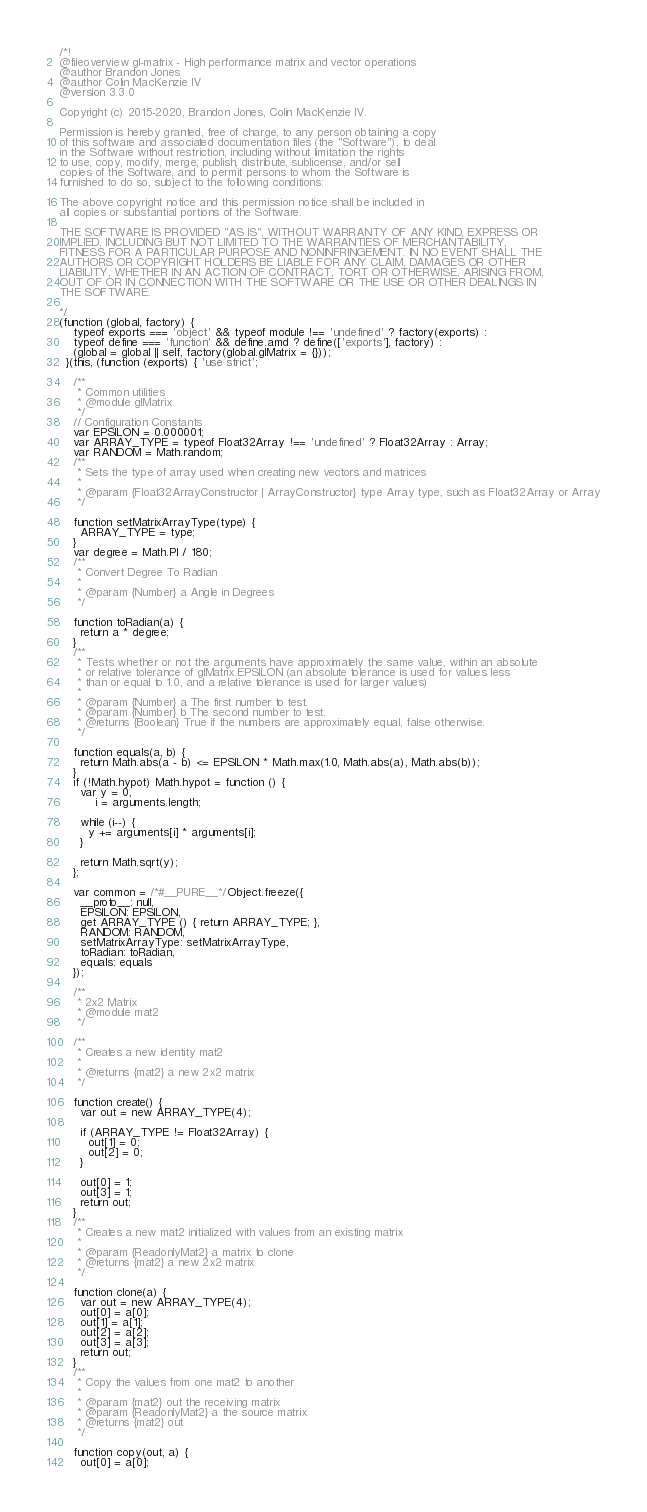<code> <loc_0><loc_0><loc_500><loc_500><_JavaScript_>
/*!
@fileoverview gl-matrix - High performance matrix and vector operations
@author Brandon Jones
@author Colin MacKenzie IV
@version 3.3.0

Copyright (c) 2015-2020, Brandon Jones, Colin MacKenzie IV.

Permission is hereby granted, free of charge, to any person obtaining a copy
of this software and associated documentation files (the "Software"), to deal
in the Software without restriction, including without limitation the rights
to use, copy, modify, merge, publish, distribute, sublicense, and/or sell
copies of the Software, and to permit persons to whom the Software is
furnished to do so, subject to the following conditions:

The above copyright notice and this permission notice shall be included in
all copies or substantial portions of the Software.

THE SOFTWARE IS PROVIDED "AS IS", WITHOUT WARRANTY OF ANY KIND, EXPRESS OR
IMPLIED, INCLUDING BUT NOT LIMITED TO THE WARRANTIES OF MERCHANTABILITY,
FITNESS FOR A PARTICULAR PURPOSE AND NONINFRINGEMENT. IN NO EVENT SHALL THE
AUTHORS OR COPYRIGHT HOLDERS BE LIABLE FOR ANY CLAIM, DAMAGES OR OTHER
LIABILITY, WHETHER IN AN ACTION OF CONTRACT, TORT OR OTHERWISE, ARISING FROM,
OUT OF OR IN CONNECTION WITH THE SOFTWARE OR THE USE OR OTHER DEALINGS IN
THE SOFTWARE.

*/
(function (global, factory) {
    typeof exports === 'object' && typeof module !== 'undefined' ? factory(exports) :
    typeof define === 'function' && define.amd ? define(['exports'], factory) :
    (global = global || self, factory(global.glMatrix = {}));
  }(this, (function (exports) { 'use strict';
  
    /**
     * Common utilities
     * @module glMatrix
     */
    // Configuration Constants
    var EPSILON = 0.000001;
    var ARRAY_TYPE = typeof Float32Array !== 'undefined' ? Float32Array : Array;
    var RANDOM = Math.random;
    /**
     * Sets the type of array used when creating new vectors and matrices
     *
     * @param {Float32ArrayConstructor | ArrayConstructor} type Array type, such as Float32Array or Array
     */
  
    function setMatrixArrayType(type) {
      ARRAY_TYPE = type;
    }
    var degree = Math.PI / 180;
    /**
     * Convert Degree To Radian
     *
     * @param {Number} a Angle in Degrees
     */
  
    function toRadian(a) {
      return a * degree;
    }
    /**
     * Tests whether or not the arguments have approximately the same value, within an absolute
     * or relative tolerance of glMatrix.EPSILON (an absolute tolerance is used for values less
     * than or equal to 1.0, and a relative tolerance is used for larger values)
     *
     * @param {Number} a The first number to test.
     * @param {Number} b The second number to test.
     * @returns {Boolean} True if the numbers are approximately equal, false otherwise.
     */
  
    function equals(a, b) {
      return Math.abs(a - b) <= EPSILON * Math.max(1.0, Math.abs(a), Math.abs(b));
    }
    if (!Math.hypot) Math.hypot = function () {
      var y = 0,
          i = arguments.length;
  
      while (i--) {
        y += arguments[i] * arguments[i];
      }
  
      return Math.sqrt(y);
    };
  
    var common = /*#__PURE__*/Object.freeze({
      __proto__: null,
      EPSILON: EPSILON,
      get ARRAY_TYPE () { return ARRAY_TYPE; },
      RANDOM: RANDOM,
      setMatrixArrayType: setMatrixArrayType,
      toRadian: toRadian,
      equals: equals
    });
  
    /**
     * 2x2 Matrix
     * @module mat2
     */
  
    /**
     * Creates a new identity mat2
     *
     * @returns {mat2} a new 2x2 matrix
     */
  
    function create() {
      var out = new ARRAY_TYPE(4);
  
      if (ARRAY_TYPE != Float32Array) {
        out[1] = 0;
        out[2] = 0;
      }
  
      out[0] = 1;
      out[3] = 1;
      return out;
    }
    /**
     * Creates a new mat2 initialized with values from an existing matrix
     *
     * @param {ReadonlyMat2} a matrix to clone
     * @returns {mat2} a new 2x2 matrix
     */
  
    function clone(a) {
      var out = new ARRAY_TYPE(4);
      out[0] = a[0];
      out[1] = a[1];
      out[2] = a[2];
      out[3] = a[3];
      return out;
    }
    /**
     * Copy the values from one mat2 to another
     *
     * @param {mat2} out the receiving matrix
     * @param {ReadonlyMat2} a the source matrix
     * @returns {mat2} out
     */
  
    function copy(out, a) {
      out[0] = a[0];</code> 